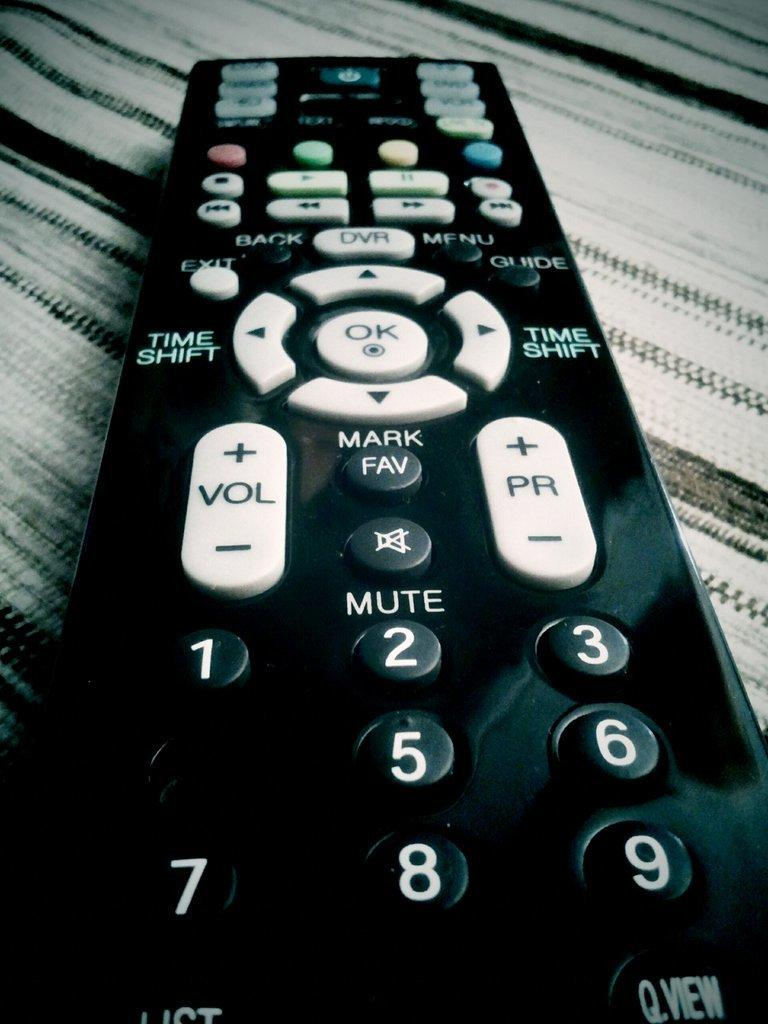<image>
Offer a succinct explanation of the picture presented. A black remote sitting on a plush surface with the mute button in the middle. 